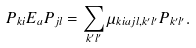Convert formula to latex. <formula><loc_0><loc_0><loc_500><loc_500>P _ { k i } E _ { a } P _ { j l } = \sum _ { k ^ { \prime } l ^ { \prime } } \mu _ { k i a j l , k ^ { \prime } l ^ { \prime } } P _ { k ^ { \prime } l ^ { \prime } } .</formula> 